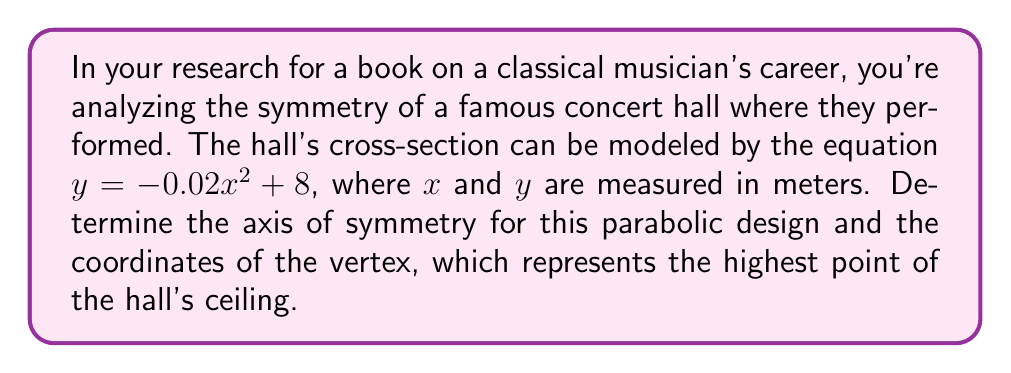Could you help me with this problem? 1) The general form of a quadratic equation is $y = ax^2 + bx + c$, where $a \neq 0$.

2) In this case, we have $y = -0.02x^2 + 8$, so $a = -0.02$, $b = 0$, and $c = 8$.

3) For any parabola, the axis of symmetry is given by the formula:

   $$x = -\frac{b}{2a}$$

4) Substituting our values:

   $$x = -\frac{0}{2(-0.02)} = 0$$

5) Therefore, the axis of symmetry is the y-axis (x = 0).

6) To find the vertex, we can use the formula:

   $$(x, y) = \left(-\frac{b}{2a}, f\left(-\frac{b}{2a}\right)\right)$$

7) We already know x = 0. For y:

   $$y = -0.02(0)^2 + 8 = 8$$

8) Thus, the vertex is at the point (0, 8).

[asy]
unitsize(10mm);
draw((-10,0)--(10,0),arrow=Arrow(TeXHead));
draw((0,-2)--(0,10),arrow=Arrow(TeXHead));
label("x",(10,0),E);
label("y",(0,10),N);
real f(real x) {return -0.02x^2+8;}
draw(graph(f,-10,10));
dot((0,8));
label("(0, 8)",(0,8),NE);
[/asy]
Answer: Axis of symmetry: x = 0; Vertex: (0, 8) 